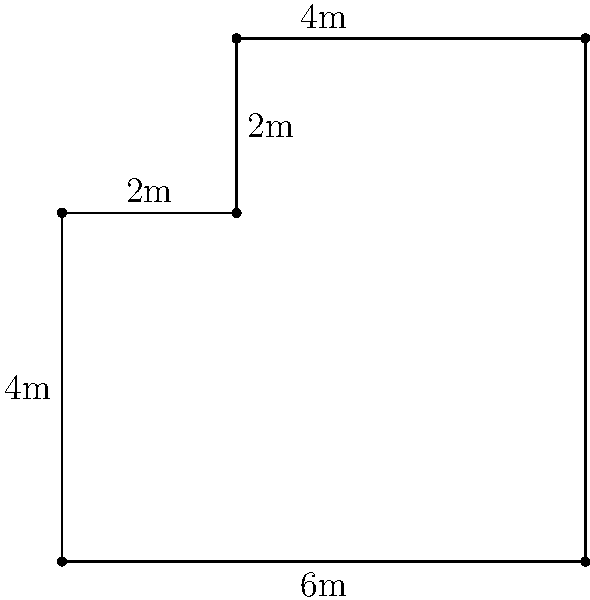Your child's teacher has assigned a practical math problem to help improve spatial reasoning. The problem involves calculating the perimeter of an L-shaped garden, as shown in the diagram. The garden's dimensions are given in meters. What is the total perimeter of this L-shaped garden? Let's approach this step-by-step:

1) First, let's identify all the sides of the L-shaped garden:
   - Left side: 4m
   - Top left: 2m
   - Top right: 4m
   - Right side: 6m
   - Bottom: 6m
   - Inner vertical: 2m

2) The perimeter is the sum of all outer sides. We don't include the inner vertical line in our calculation.

3) Let's add up all the outer sides:
   $$ 4m + 2m + 4m + 6m + 6m = 22m $$

4) Therefore, the total perimeter of the L-shaped garden is 22 meters.

This problem helps your child practice addition and understand the concept of perimeter in real-world scenarios, which aligns with the teacher's goal of improving reading comprehension through practical math applications.
Answer: 22m 